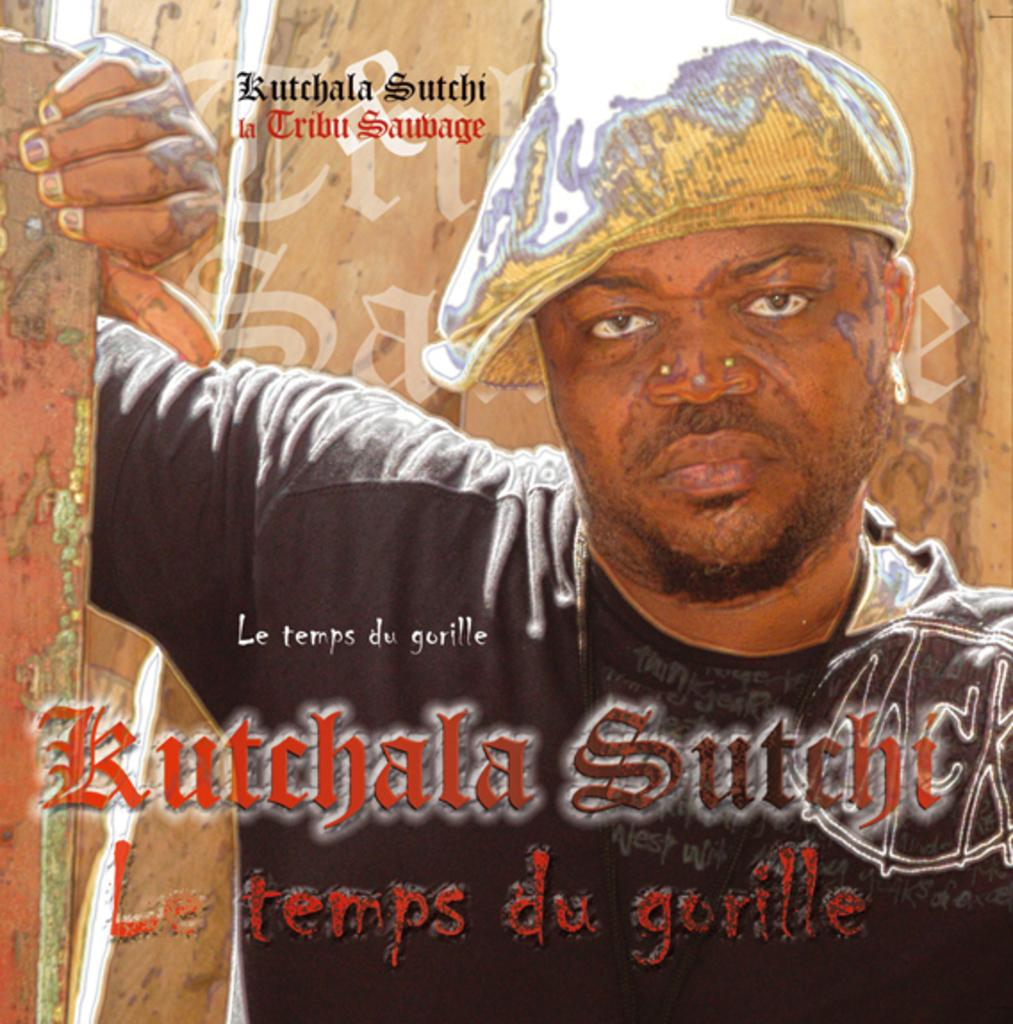What is the main subject of the poster in the image? The main subject of the poster is a person. What is the person wearing in the image? The person is wearing a black color T-shirt. What is the person doing in the image? The person is holding a pole with one hand. What can be seen in the background of the poster? There is a wall in the background of the image. What else is featured on the poster besides the image? There are texts on the poster. What type of beds are visible in the image? There are no beds present in the image; it features a person holding a pole in front of a wall. What is the person's opinion on prose in the image? There is no indication of the person's opinion on prose in the image. 